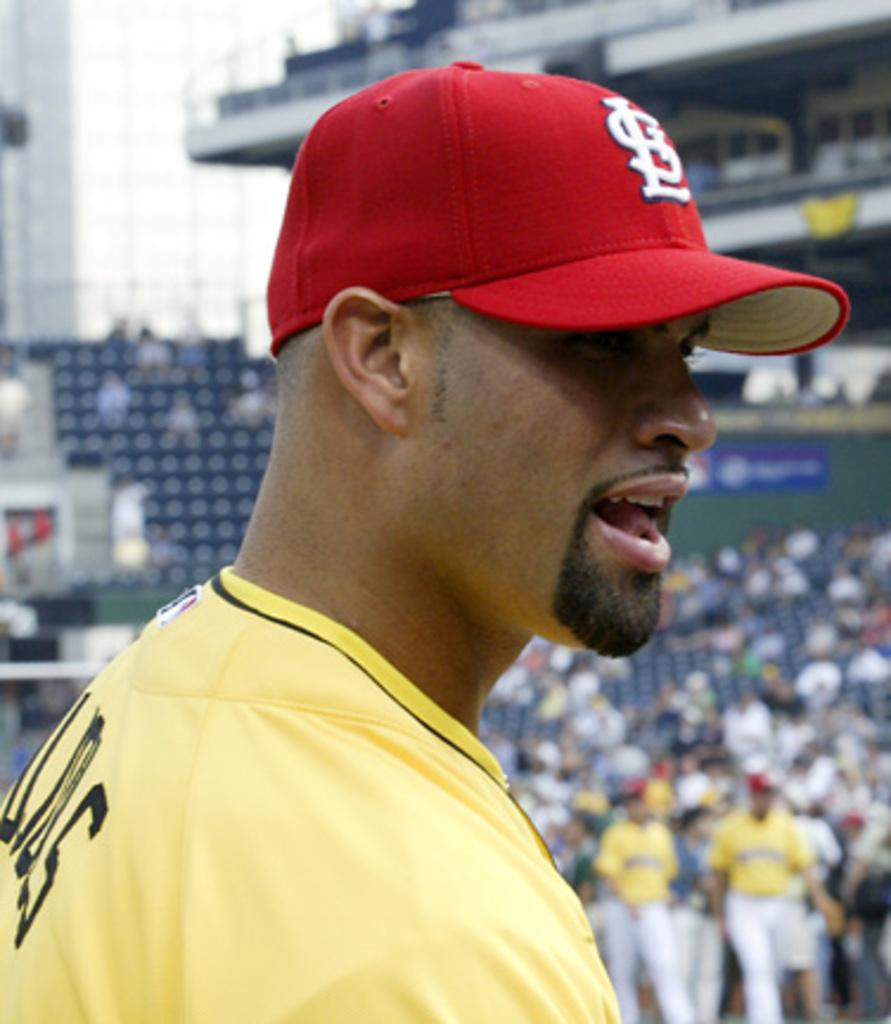<image>
Relay a brief, clear account of the picture shown. A baseball player with a hat that says STL which stands for St Louis Cardinals 